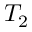Convert formula to latex. <formula><loc_0><loc_0><loc_500><loc_500>T _ { 2 }</formula> 